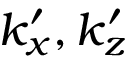<formula> <loc_0><loc_0><loc_500><loc_500>k _ { x } ^ { \prime } , k _ { z } ^ { \prime }</formula> 